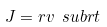Convert formula to latex. <formula><loc_0><loc_0><loc_500><loc_500>J = r v \ s u b r { t }</formula> 